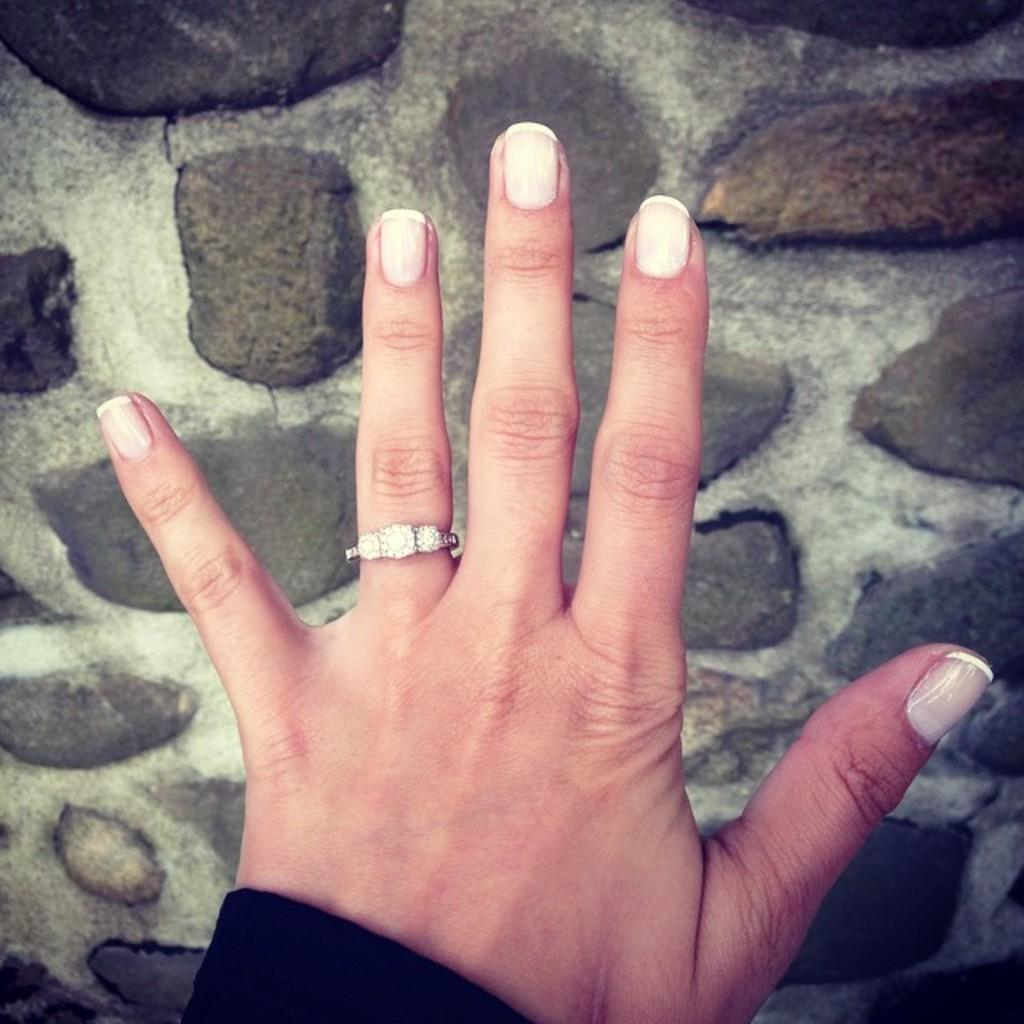What is the focus of the image? The image is zoomed in on a hand of a person. What can be seen on the hand of the person? The person is wearing a ring on their ring finger. What is visible in the background of the image? There is ground visible in the background of the image, and there are gravels present. What type of honey can be seen dripping from the vein in the image? There is no honey or vein present in the image. What kind of paste is being applied to the hand in the image? There is no paste being applied to the hand in the image; it only shows a ring on the ring finger. 